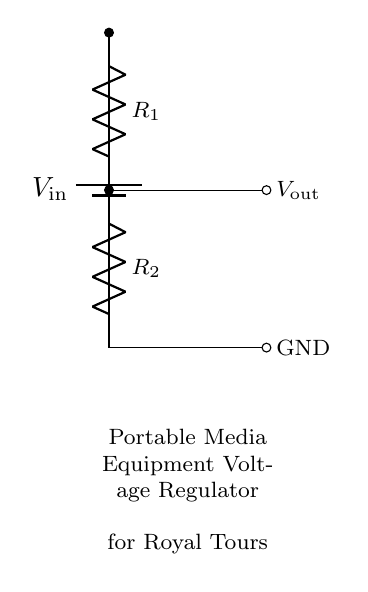What is the type of circuit used here? The circuit is a voltage divider, which consists of two resistors in series that divide the input voltage into a lower output voltage. This is a fundamental configuration often used for adjusting voltage levels in electronic devices.
Answer: voltage divider What are the components seen in the diagram? The components in the diagram include a battery, two resistors labeled R1 and R2, and connections that indicate input and output voltages. The combination of these components defines the function of the circuit.
Answer: battery, R1, R2 What is the purpose of this circuit? The purpose of this circuit is to regulate the voltage for powering portable media equipment during royal tours, ensuring stable operation of the devices.
Answer: voltage regulation What is the output voltage dependent on? The output voltage is dependent on the values of the resistors R1 and R2 and the input voltage Vin. The formula used to calculate the output voltage in a voltage divider is Vout = Vin * (R2 / (R1 + R2)).
Answer: resistor values and input voltage If R1 is twice the value of R2, what happens to the output voltage? In this case, if R1 is twice R2, the output voltage will equal one-third of the input voltage. This is because the voltage divider formula simplifies under those specific conditions, showing how input voltage is distributed between the two resistors based on their values.
Answer: one-third of Vin What is the ground reference point in the circuit? The ground reference point is the bottom node where R2 connects, indicating that it serves as the common return path for the current and is at zero volts in relation to the other voltages in the circuit.
Answer: GND How is the output voltage represented in the circuit diagram? The output voltage is indicated by the label Vout next to the connection point after the resistor R2, showing where the regulated voltage can be taken for use in the portable media equipment.
Answer: Vout 